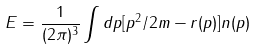<formula> <loc_0><loc_0><loc_500><loc_500>E = \frac { 1 } { ( 2 \pi ) ^ { 3 } } \int d { p } [ p ^ { 2 } / 2 m - r ( p ) ] n ( p )</formula> 